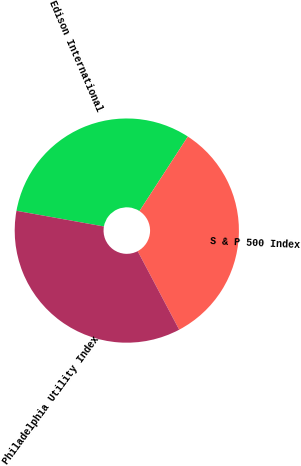Convert chart to OTSL. <chart><loc_0><loc_0><loc_500><loc_500><pie_chart><fcel>Edison International<fcel>S & P 500 Index<fcel>Philadelphia Utility Index<nl><fcel>31.34%<fcel>33.1%<fcel>35.56%<nl></chart> 